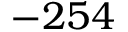Convert formula to latex. <formula><loc_0><loc_0><loc_500><loc_500>- 2 5 4</formula> 